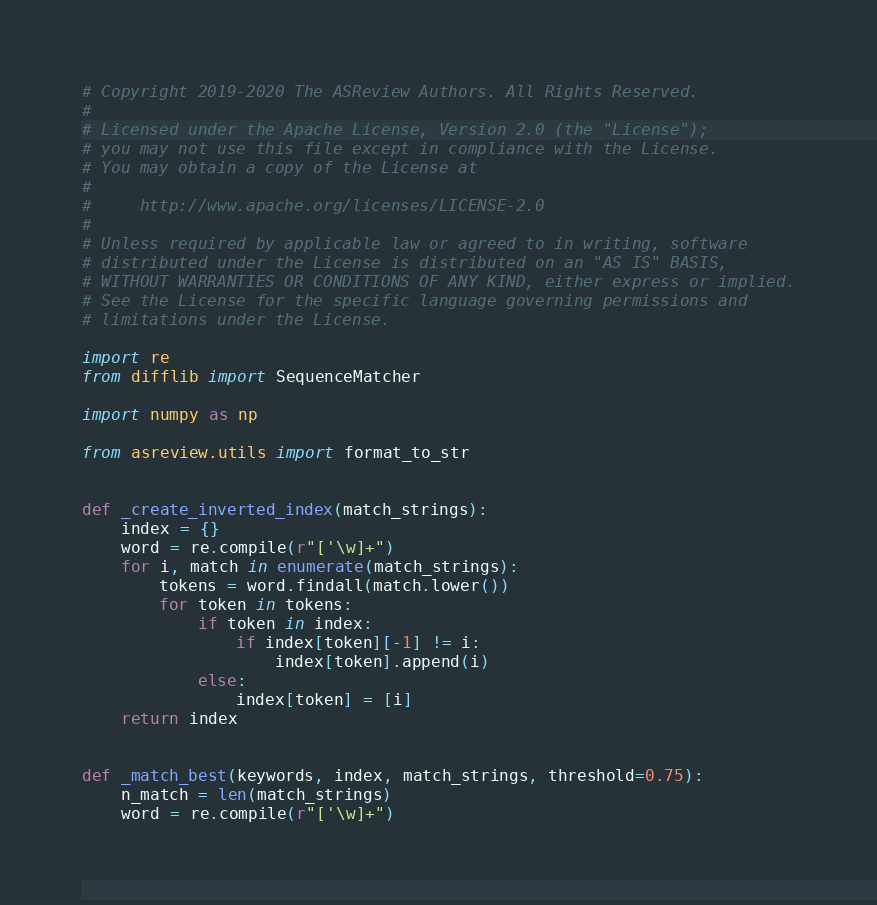<code> <loc_0><loc_0><loc_500><loc_500><_Python_># Copyright 2019-2020 The ASReview Authors. All Rights Reserved.
#
# Licensed under the Apache License, Version 2.0 (the "License");
# you may not use this file except in compliance with the License.
# You may obtain a copy of the License at
#
#     http://www.apache.org/licenses/LICENSE-2.0
#
# Unless required by applicable law or agreed to in writing, software
# distributed under the License is distributed on an "AS IS" BASIS,
# WITHOUT WARRANTIES OR CONDITIONS OF ANY KIND, either express or implied.
# See the License for the specific language governing permissions and
# limitations under the License.

import re
from difflib import SequenceMatcher

import numpy as np

from asreview.utils import format_to_str


def _create_inverted_index(match_strings):
    index = {}
    word = re.compile(r"['\w]+")
    for i, match in enumerate(match_strings):
        tokens = word.findall(match.lower())
        for token in tokens:
            if token in index:
                if index[token][-1] != i:
                    index[token].append(i)
            else:
                index[token] = [i]
    return index


def _match_best(keywords, index, match_strings, threshold=0.75):
    n_match = len(match_strings)
    word = re.compile(r"['\w]+")</code> 